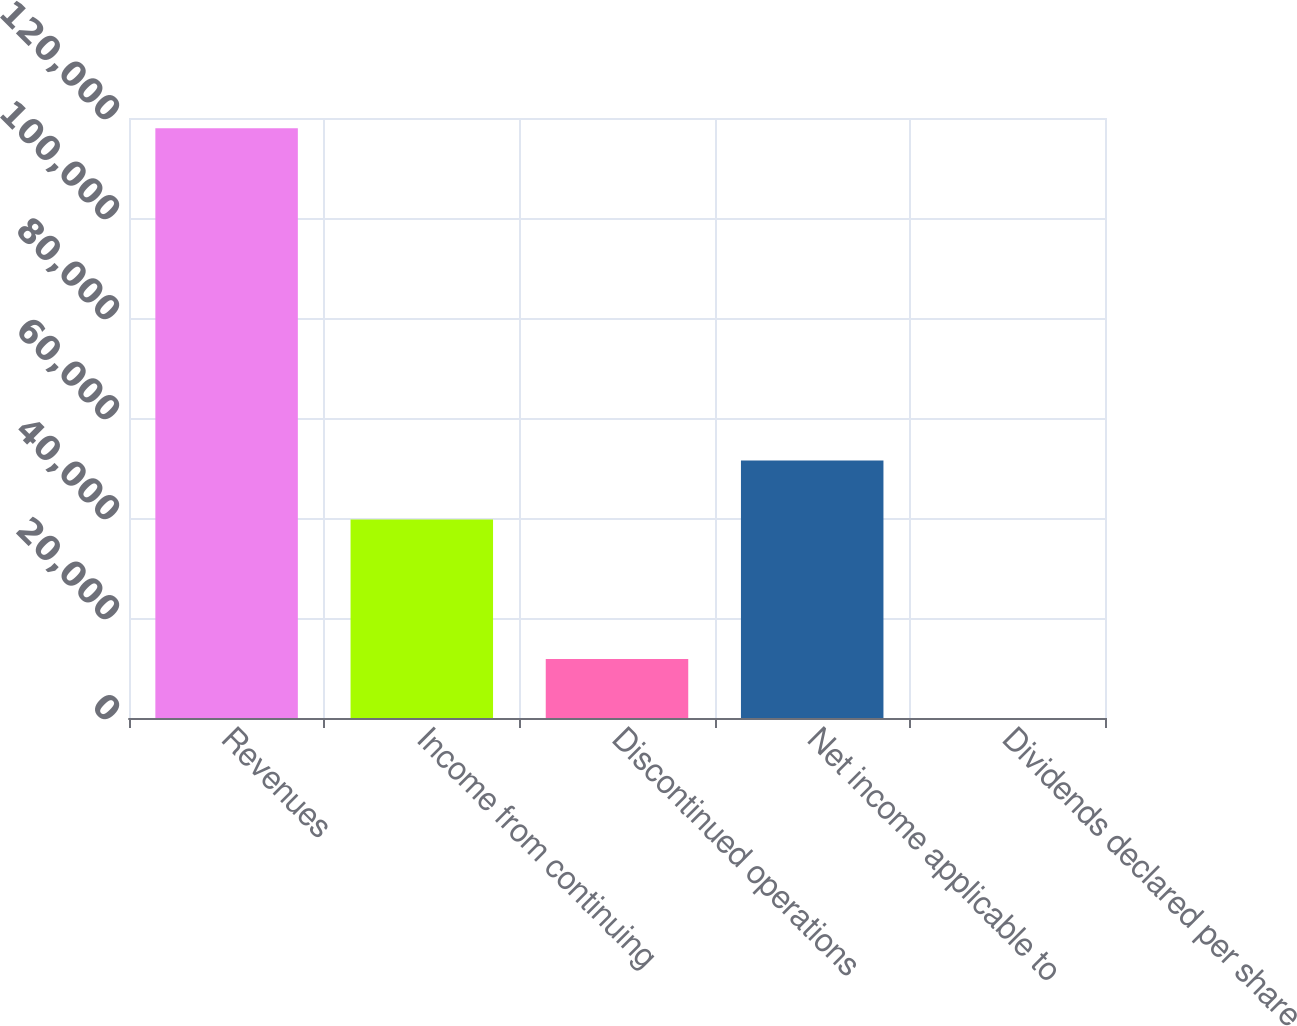Convert chart. <chart><loc_0><loc_0><loc_500><loc_500><bar_chart><fcel>Revenues<fcel>Income from continuing<fcel>Discontinued operations<fcel>Net income applicable to<fcel>Dividends declared per share<nl><fcel>117937<fcel>39716<fcel>11794.1<fcel>51509.7<fcel>0.4<nl></chart> 